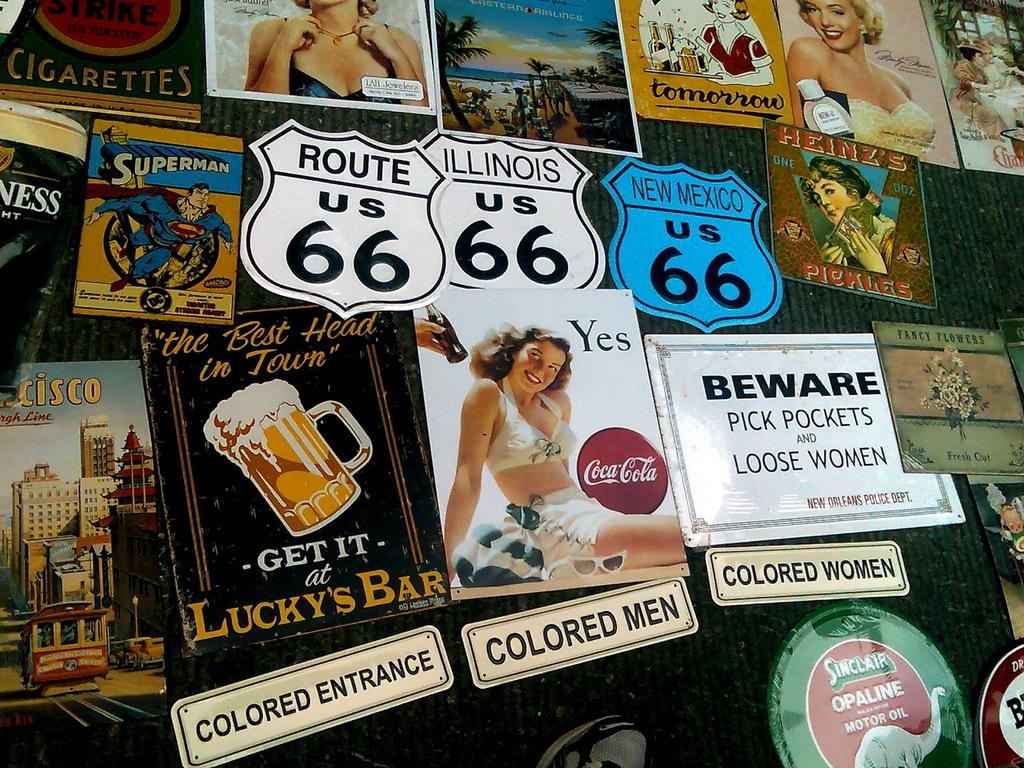What objects are present in large quantities in the image? There are many boards in the image. What type of printed material can be seen in the image? There are posters in the image. What color is the surface to which the boards and posters are attached? The boards and posters are attached to a black color surface. Can you see any snails crawling on the boards in the image? There are no snails present in the image. What type of stone is used to create the boards in the image? The image does not provide information about the material used to create the boards, but there is no indication of stone being used. 